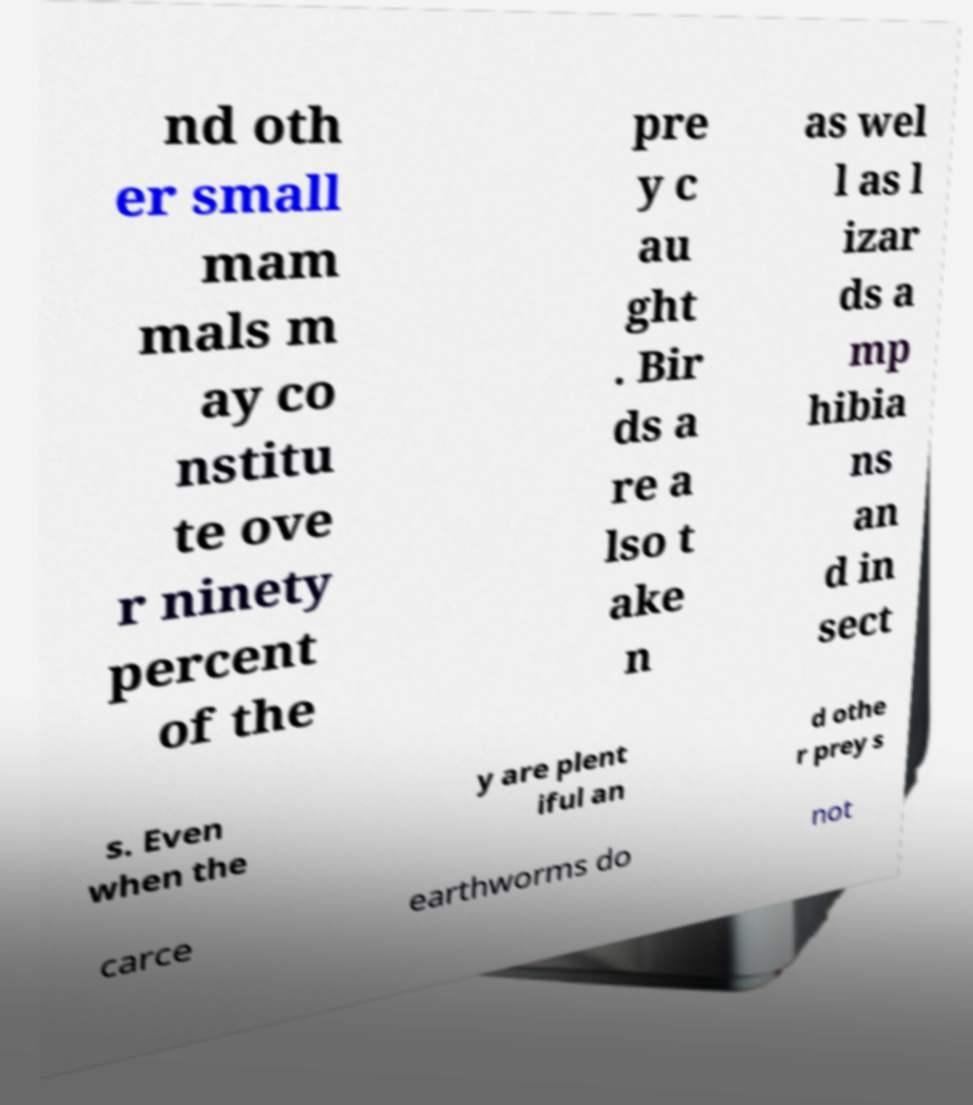Could you assist in decoding the text presented in this image and type it out clearly? nd oth er small mam mals m ay co nstitu te ove r ninety percent of the pre y c au ght . Bir ds a re a lso t ake n as wel l as l izar ds a mp hibia ns an d in sect s. Even when the y are plent iful an d othe r prey s carce earthworms do not 